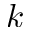Convert formula to latex. <formula><loc_0><loc_0><loc_500><loc_500>{ k }</formula> 